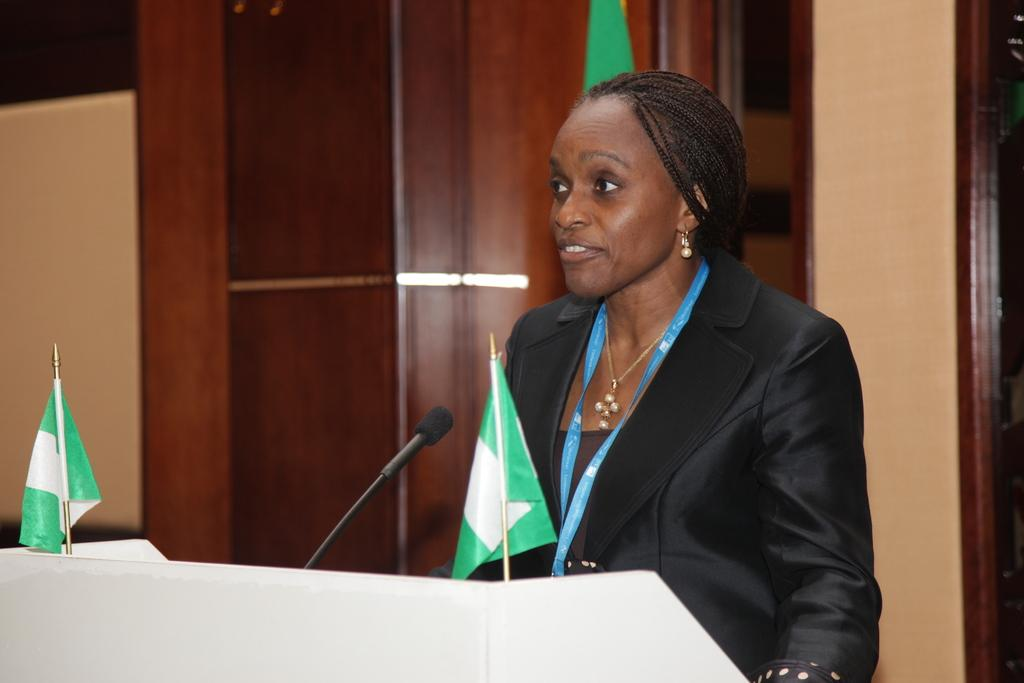What is the woman in the image doing? The woman is standing in front of the podium. What can be seen on the podium? There are two flags and a microphone on the podium. What is the background of the image made of? There is a wooden wall in the background. How many feet are visible in the image? There is no mention of feet in the image, so it is not possible to determine how many are visible. 